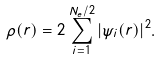<formula> <loc_0><loc_0><loc_500><loc_500>\rho ( { r } ) = 2 \sum _ { i = 1 } ^ { { N _ { e } } / 2 } | \psi _ { i } ( { r } ) | ^ { 2 } .</formula> 